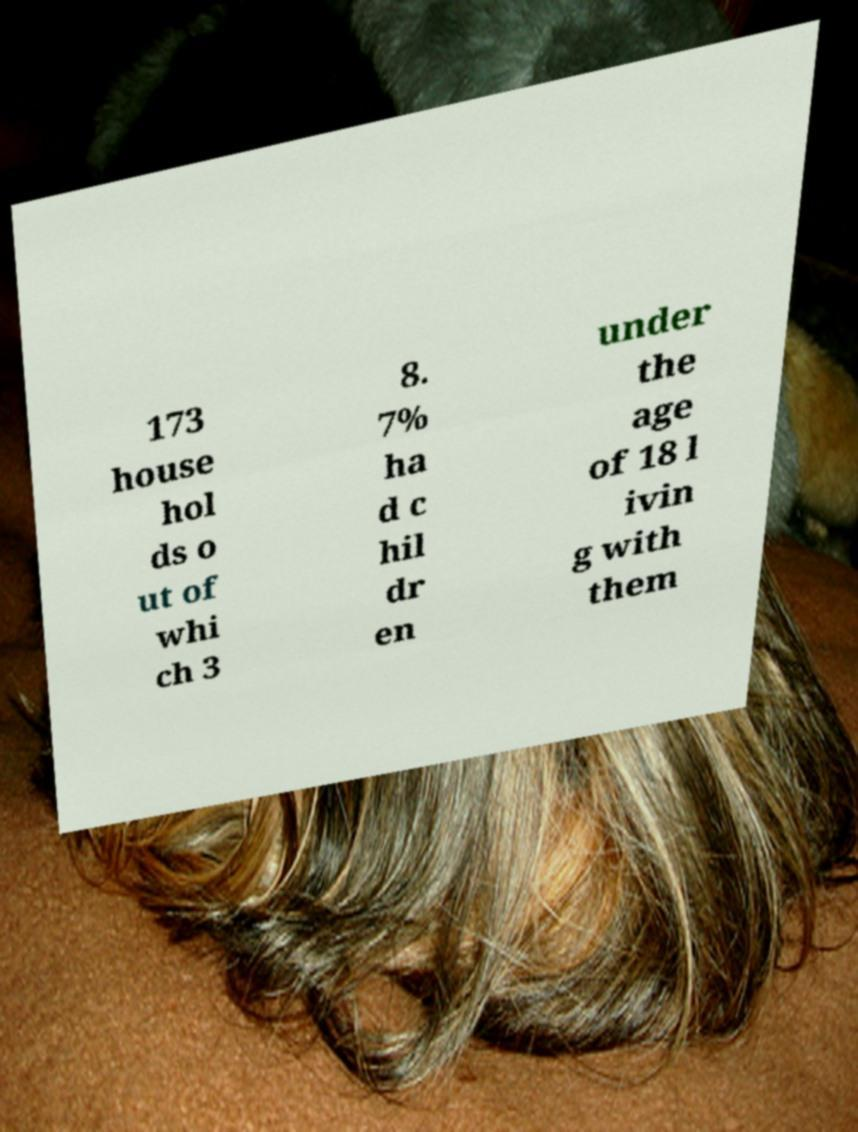What messages or text are displayed in this image? I need them in a readable, typed format. 173 house hol ds o ut of whi ch 3 8. 7% ha d c hil dr en under the age of 18 l ivin g with them 